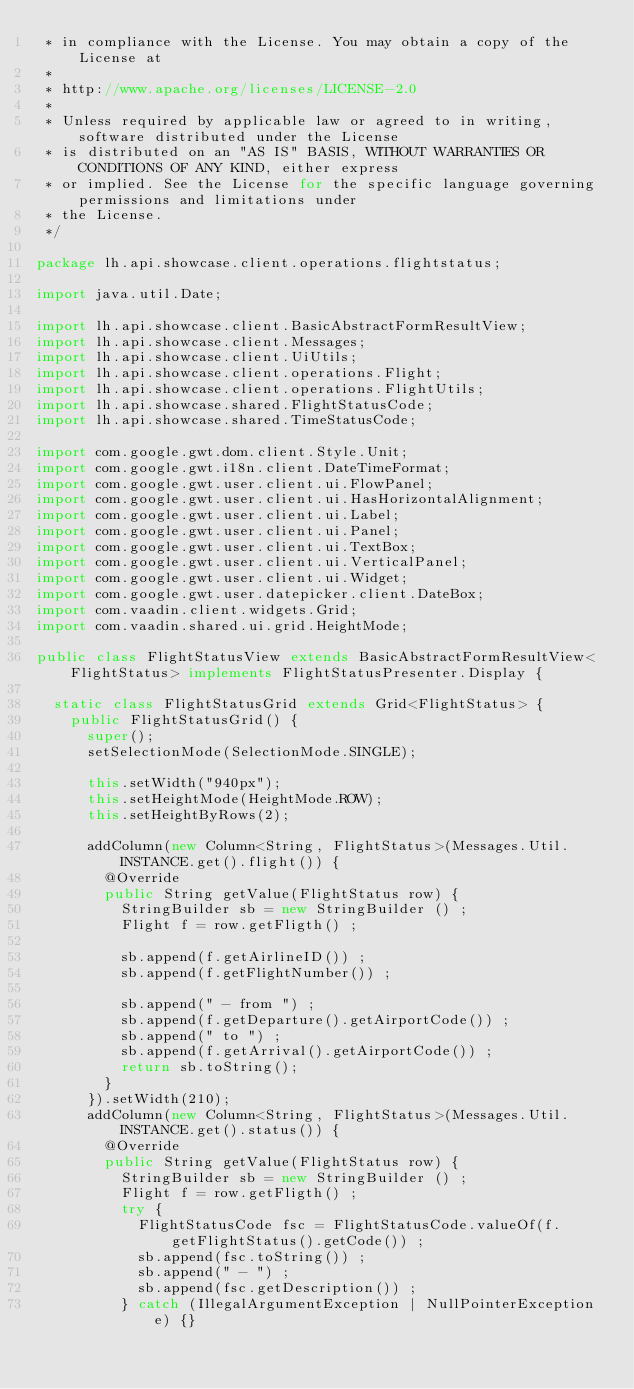<code> <loc_0><loc_0><loc_500><loc_500><_Java_> * in compliance with the License. You may obtain a copy of the License at
 * 
 * http://www.apache.org/licenses/LICENSE-2.0
 * 
 * Unless required by applicable law or agreed to in writing, software distributed under the License
 * is distributed on an "AS IS" BASIS, WITHOUT WARRANTIES OR CONDITIONS OF ANY KIND, either express
 * or implied. See the License for the specific language governing permissions and limitations under
 * the License.
 */

package lh.api.showcase.client.operations.flightstatus;

import java.util.Date;

import lh.api.showcase.client.BasicAbstractFormResultView;
import lh.api.showcase.client.Messages;
import lh.api.showcase.client.UiUtils;
import lh.api.showcase.client.operations.Flight;
import lh.api.showcase.client.operations.FlightUtils;
import lh.api.showcase.shared.FlightStatusCode;
import lh.api.showcase.shared.TimeStatusCode;

import com.google.gwt.dom.client.Style.Unit;
import com.google.gwt.i18n.client.DateTimeFormat;
import com.google.gwt.user.client.ui.FlowPanel;
import com.google.gwt.user.client.ui.HasHorizontalAlignment;
import com.google.gwt.user.client.ui.Label;
import com.google.gwt.user.client.ui.Panel;
import com.google.gwt.user.client.ui.TextBox;
import com.google.gwt.user.client.ui.VerticalPanel;
import com.google.gwt.user.client.ui.Widget;
import com.google.gwt.user.datepicker.client.DateBox;
import com.vaadin.client.widgets.Grid;
import com.vaadin.shared.ui.grid.HeightMode;

public class FlightStatusView extends BasicAbstractFormResultView<FlightStatus> implements FlightStatusPresenter.Display {
	
	static class FlightStatusGrid extends Grid<FlightStatus> {
		public FlightStatusGrid() {
			super();
			setSelectionMode(SelectionMode.SINGLE);

			this.setWidth("940px");
			this.setHeightMode(HeightMode.ROW);
			this.setHeightByRows(2);
			
			addColumn(new Column<String, FlightStatus>(Messages.Util.INSTANCE.get().flight()) {
				@Override
				public String getValue(FlightStatus row) {
					StringBuilder sb = new StringBuilder () ;
					Flight f = row.getFligth() ;
					
					sb.append(f.getAirlineID()) ;
					sb.append(f.getFlightNumber()) ;
					
					sb.append(" - from ") ;
					sb.append(f.getDeparture().getAirportCode()) ;
					sb.append(" to ") ;
					sb.append(f.getArrival().getAirportCode()) ;
					return sb.toString();
				}
			}).setWidth(210);
			addColumn(new Column<String, FlightStatus>(Messages.Util.INSTANCE.get().status()) {
				@Override
				public String getValue(FlightStatus row) {
					StringBuilder sb = new StringBuilder () ;
					Flight f = row.getFligth() ;
					try {
						FlightStatusCode fsc = FlightStatusCode.valueOf(f.getFlightStatus().getCode()) ;
						sb.append(fsc.toString()) ;
						sb.append(" - ") ;
						sb.append(fsc.getDescription()) ;
					} catch (IllegalArgumentException | NullPointerException e) {}			</code> 